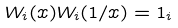Convert formula to latex. <formula><loc_0><loc_0><loc_500><loc_500>W _ { i } ( x ) W _ { i } ( 1 / x ) = 1 _ { i }</formula> 